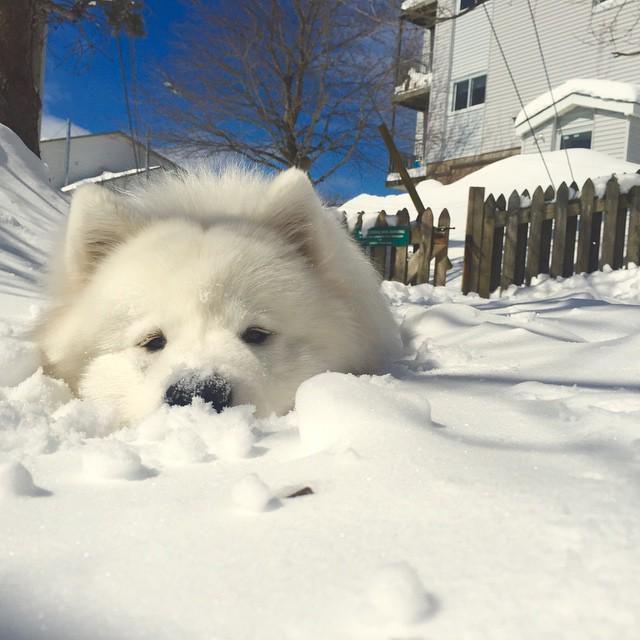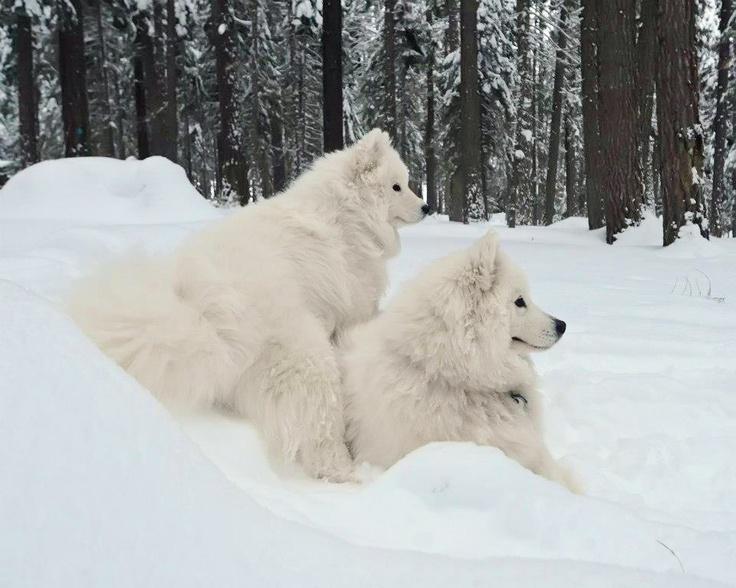The first image is the image on the left, the second image is the image on the right. For the images shown, is this caption "There are exactly three dogs." true? Answer yes or no. Yes. The first image is the image on the left, the second image is the image on the right. Evaluate the accuracy of this statement regarding the images: "One image shows two white dogs close together in the snow, and the other shows a single white dog in a snowy scene.". Is it true? Answer yes or no. Yes. 